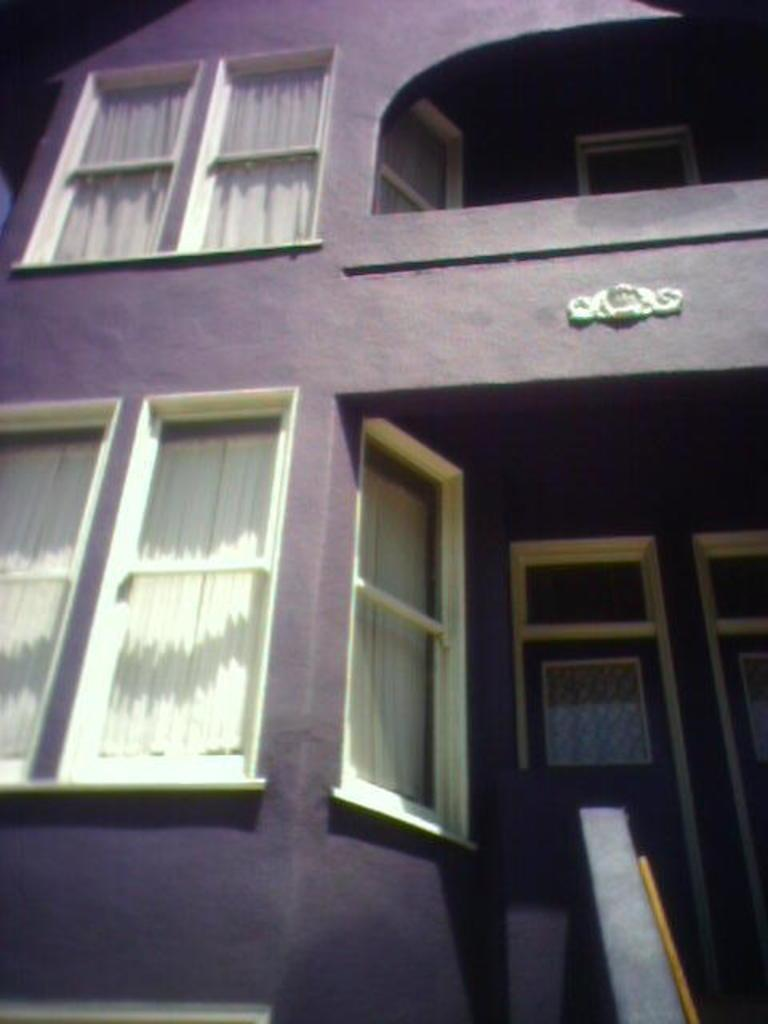What type of structure is visible in the image? There is a building in the image. What feature can be seen on the building? The building has windows. What is the color of the windows? The windows are white in color. What is behind the windows? There are curtains behind the windows. What is the color of the curtains? The curtains are white in color. How many apples are in the basket on the windowsill? There is no basket or apple present in the image. What is the interest rate for the loan mentioned in the image? There is no mention of a loan or interest rate in the image. 